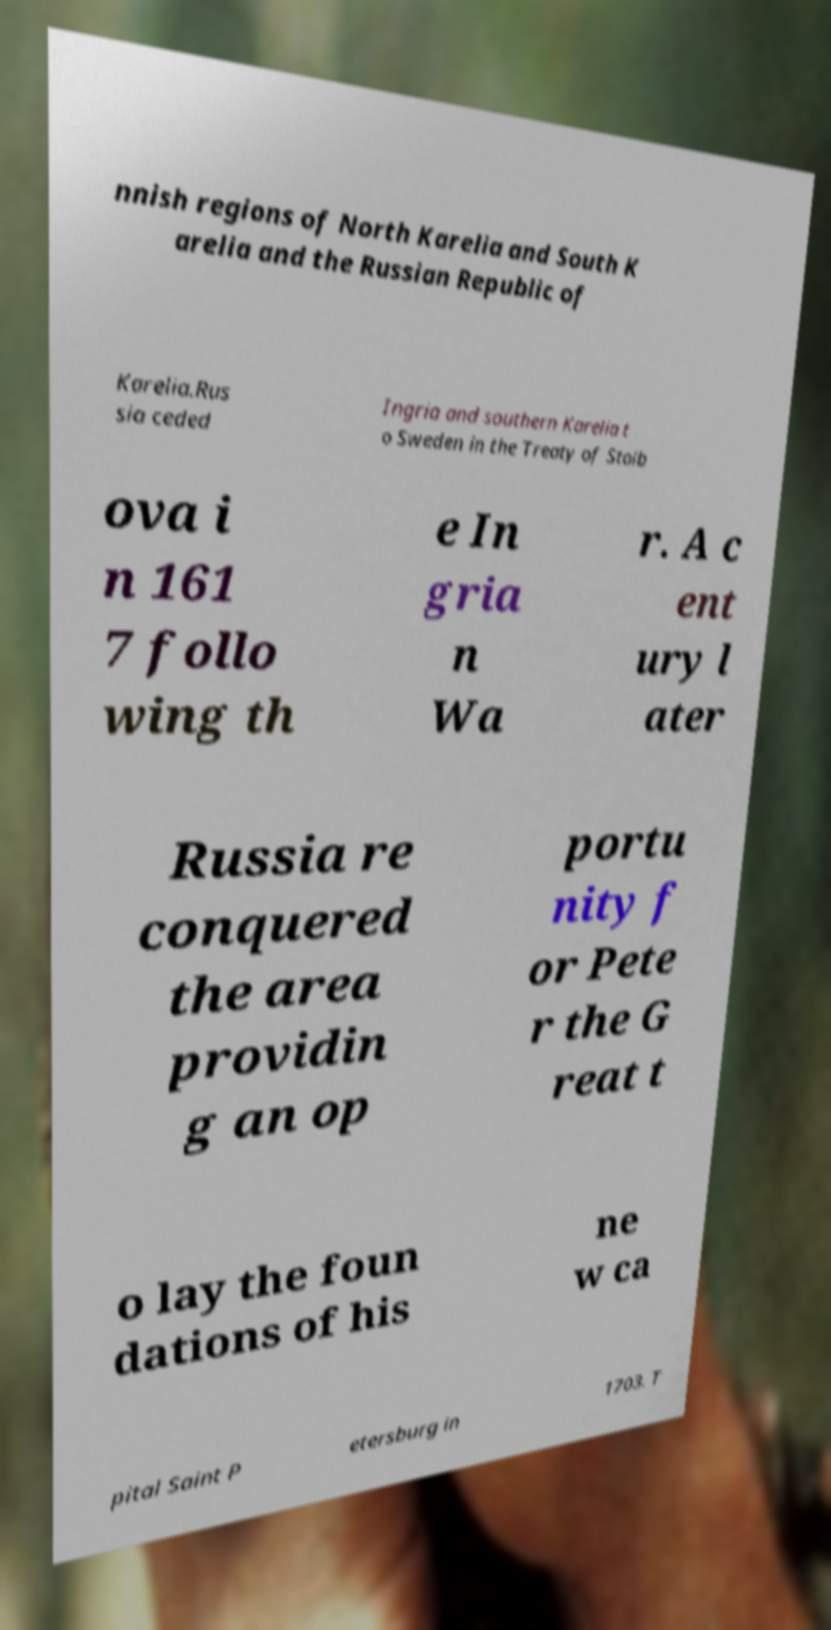Please identify and transcribe the text found in this image. nnish regions of North Karelia and South K arelia and the Russian Republic of Karelia.Rus sia ceded Ingria and southern Karelia t o Sweden in the Treaty of Stolb ova i n 161 7 follo wing th e In gria n Wa r. A c ent ury l ater Russia re conquered the area providin g an op portu nity f or Pete r the G reat t o lay the foun dations of his ne w ca pital Saint P etersburg in 1703. T 